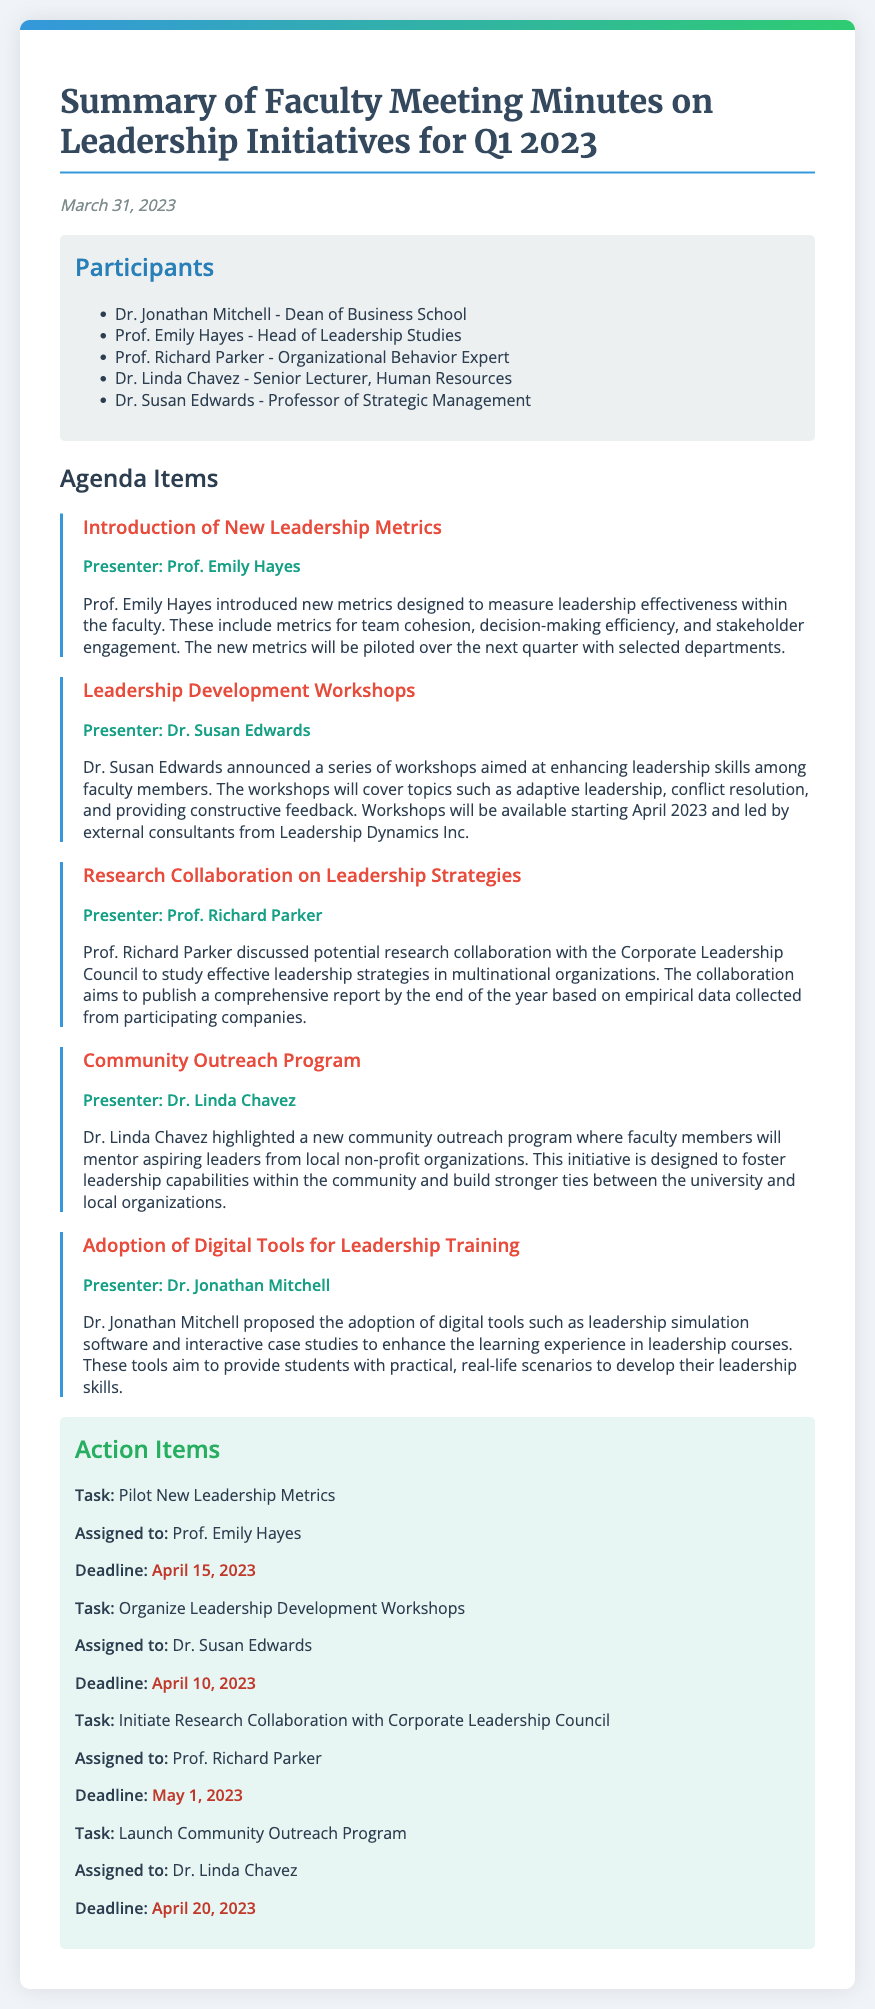What date was the faculty meeting held? The date of the faculty meeting is provided in the document, which is March 31, 2023.
Answer: March 31, 2023 Who presented the topic on Leadership Development Workshops? The document explicitly states that Dr. Susan Edwards introduced the topic of Leadership Development Workshops.
Answer: Dr. Susan Edwards What is one of the new metrics introduced to measure leadership effectiveness? The document mentions various metrics; one example provided is team cohesion.
Answer: Team cohesion When is the deadline to organize Leadership Development Workshops? The deadline for this task, as stated in the action items section, is April 10, 2023.
Answer: April 10, 2023 Which participant is the Dean of the Business School? The document lists Dr. Jonathan Mitchell as the Dean of the Business School.
Answer: Dr. Jonathan Mitchell What is the main goal of the community outreach program? The document outlines that the aim of the outreach program is to foster leadership capabilities in the community.
Answer: Foster leadership capabilities What is the name of the consulting company involved in the workshops? The consultant mentioned in the document for the workshops is Leadership Dynamics Inc.
Answer: Leadership Dynamics Inc How many days are there between the meeting date and the deadline for piloting new leadership metrics? The deadline to pilot new leadership metrics is April 15, 2023, which is 15 days after the meeting on March 31, 2023.
Answer: 15 days What kind of programs does the document detail? The document focuses on leadership initiatives that aim to improve faculty development and community engagement.
Answer: Leadership initiatives 